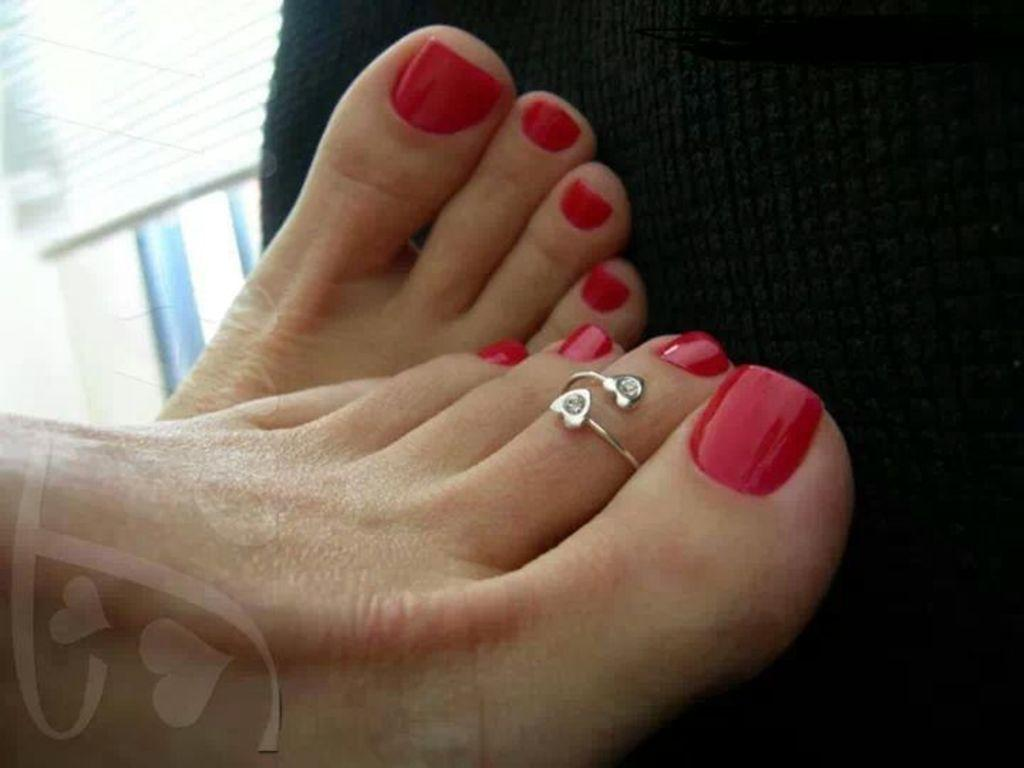What body part is visible in the image? There is a person's legs in the image. What accessory is the person wearing on their legs? The person's legs are wearing a toe ring. What type of material can be seen in the background of the image? There is cloth in the background of the image. What type of structure is visible in the background of the image? There is a wall in the background of the image. What is the person's level of wealth based on the image? The image does not provide any information about the person's wealth, so it cannot be determined from the image. 